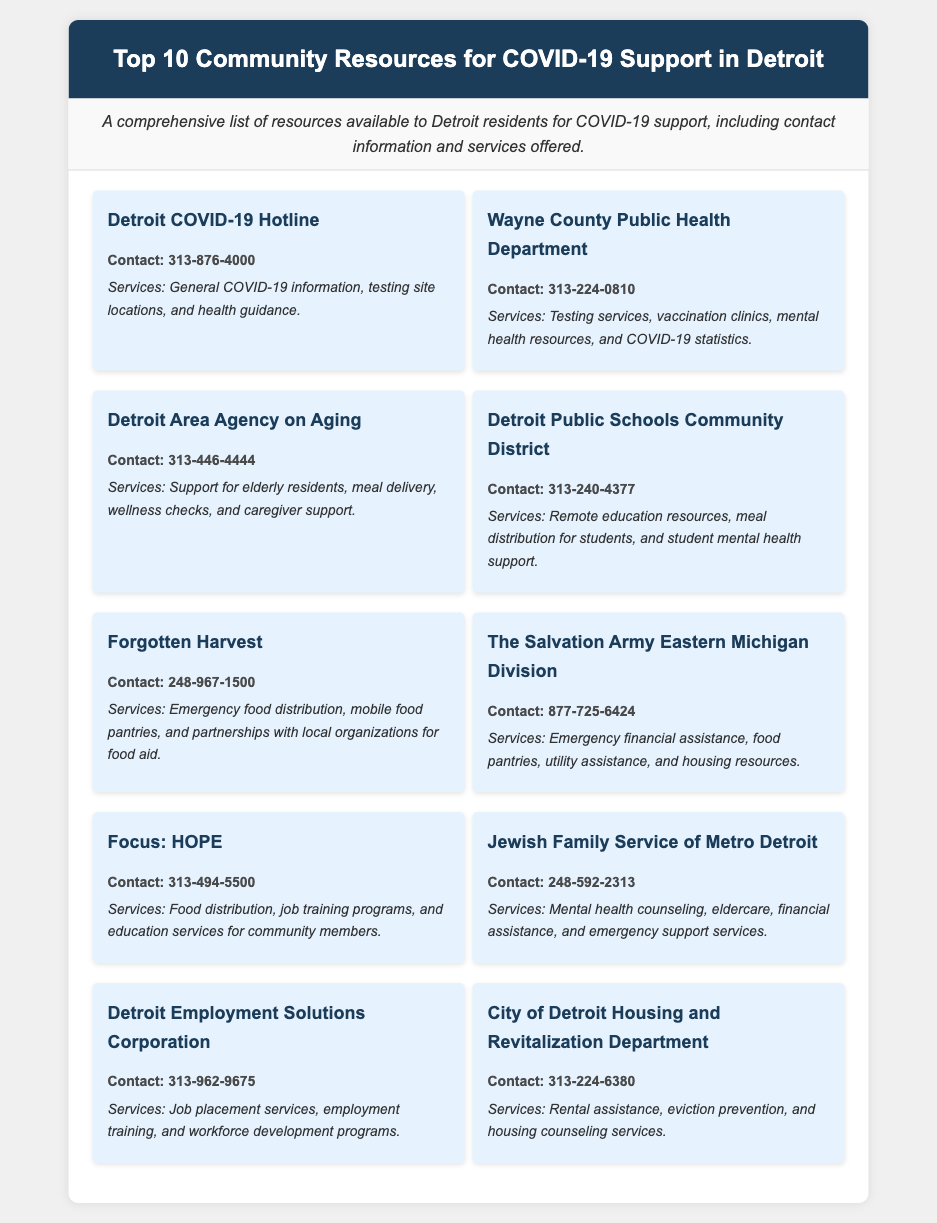what is the contact number for the Detroit COVID-19 Hotline? The document states that the contact number for the Detroit COVID-19 Hotline is 313-876-4000.
Answer: 313-876-4000 how many community resources are listed in the document? The document explicitly mentions that there are ten community resources listed for COVID-19 support in Detroit.
Answer: 10 which organization provides emergency food distribution? From the document, it is stated that Forgotten Harvest offers emergency food distribution services.
Answer: Forgotten Harvest what service is offered by the Wayne County Public Health Department? The document outlines several services, including testing services provided by the Wayne County Public Health Department.
Answer: Testing services which resource is specifically focused on elderly residents? The document refers to the Detroit Area Agency on Aging, which is specifically focused on elderly residents.
Answer: Detroit Area Agency on Aging what type of assistance does The Salvation Army Eastern Michigan Division provide? The document lists multiple types of assistance, with emergency financial assistance being one service provided by The Salvation Army Eastern Michigan Division.
Answer: Emergency financial assistance name one service offered by Focus: HOPE. According to the document, one service offered by Focus: HOPE is job training programs.
Answer: Job training programs which resource includes mental health resources in its services? The document indicates that the Wayne County Public Health Department includes mental health resources among its services.
Answer: Wayne County Public Health Department who can be contacted at 313-240-4377? The document states that the Detroit Public Schools Community District can be contacted at this number.
Answer: Detroit Public Schools Community District 